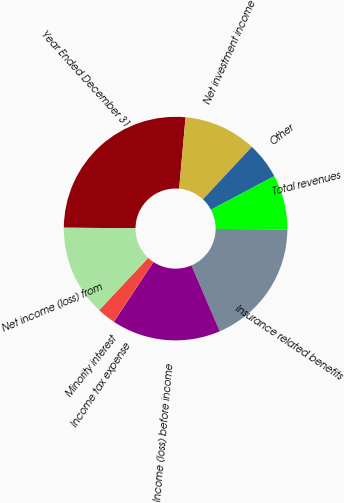Convert chart to OTSL. <chart><loc_0><loc_0><loc_500><loc_500><pie_chart><fcel>Year Ended December 31<fcel>Net investment income<fcel>Other<fcel>Total revenues<fcel>Insurance related benefits<fcel>Income (loss) before income<fcel>Income tax expense<fcel>Minority interest<fcel>Net income (loss) from<nl><fcel>26.29%<fcel>10.53%<fcel>5.27%<fcel>7.9%<fcel>18.41%<fcel>15.78%<fcel>0.02%<fcel>2.64%<fcel>13.15%<nl></chart> 